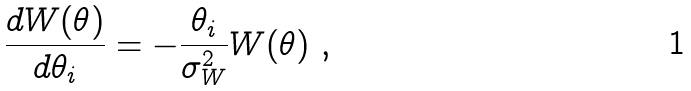<formula> <loc_0><loc_0><loc_500><loc_500>\frac { d W ( { \theta } ) } { d \theta _ { i } } = - \frac { \theta _ { i } } { \sigma _ { W } ^ { 2 } } W ( { \theta } ) \ ,</formula> 